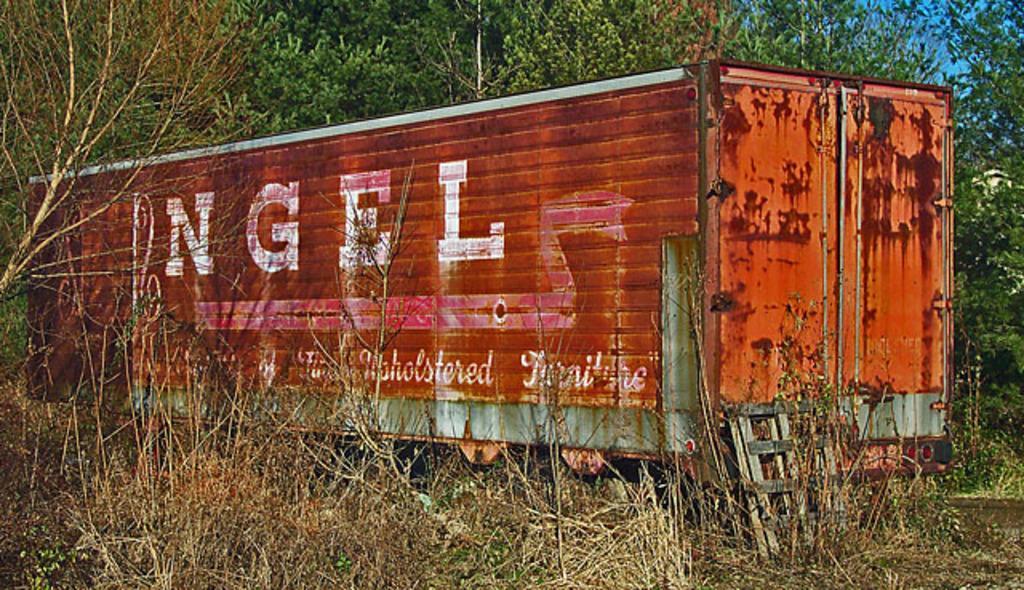Can you describe this image briefly? In this picture we can see a container, plants, trees, some objects and in the background we can see the sky. 